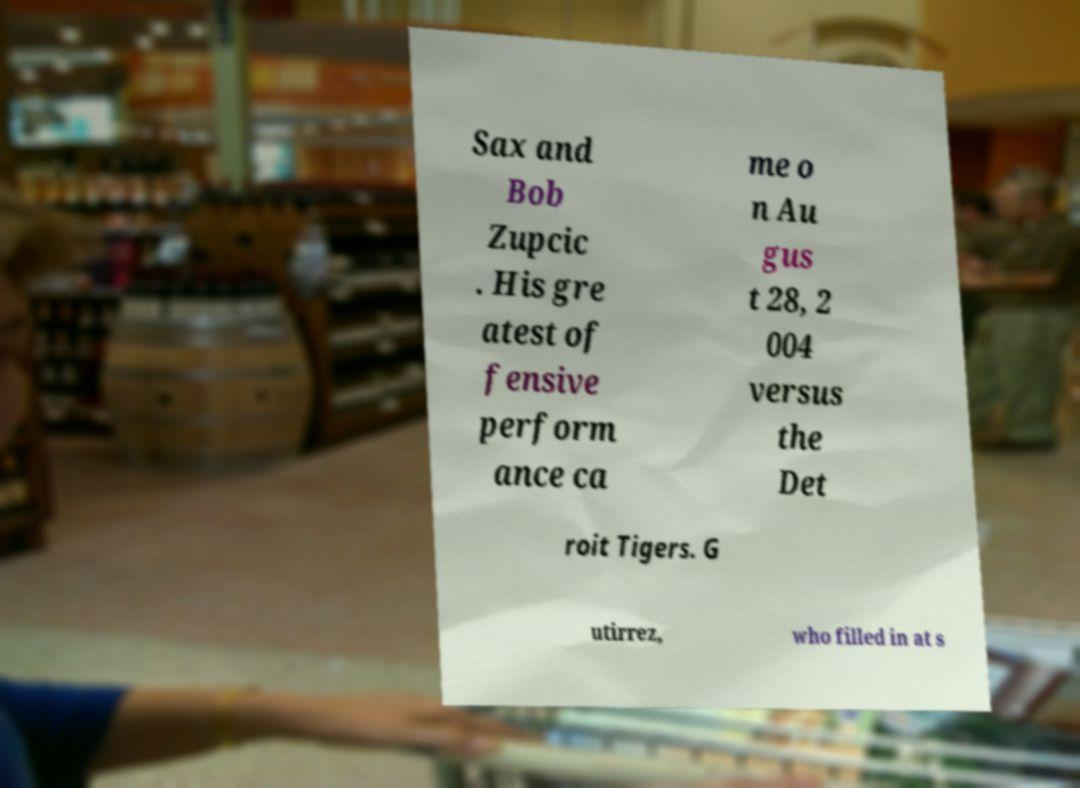Can you accurately transcribe the text from the provided image for me? Sax and Bob Zupcic . His gre atest of fensive perform ance ca me o n Au gus t 28, 2 004 versus the Det roit Tigers. G utirrez, who filled in at s 